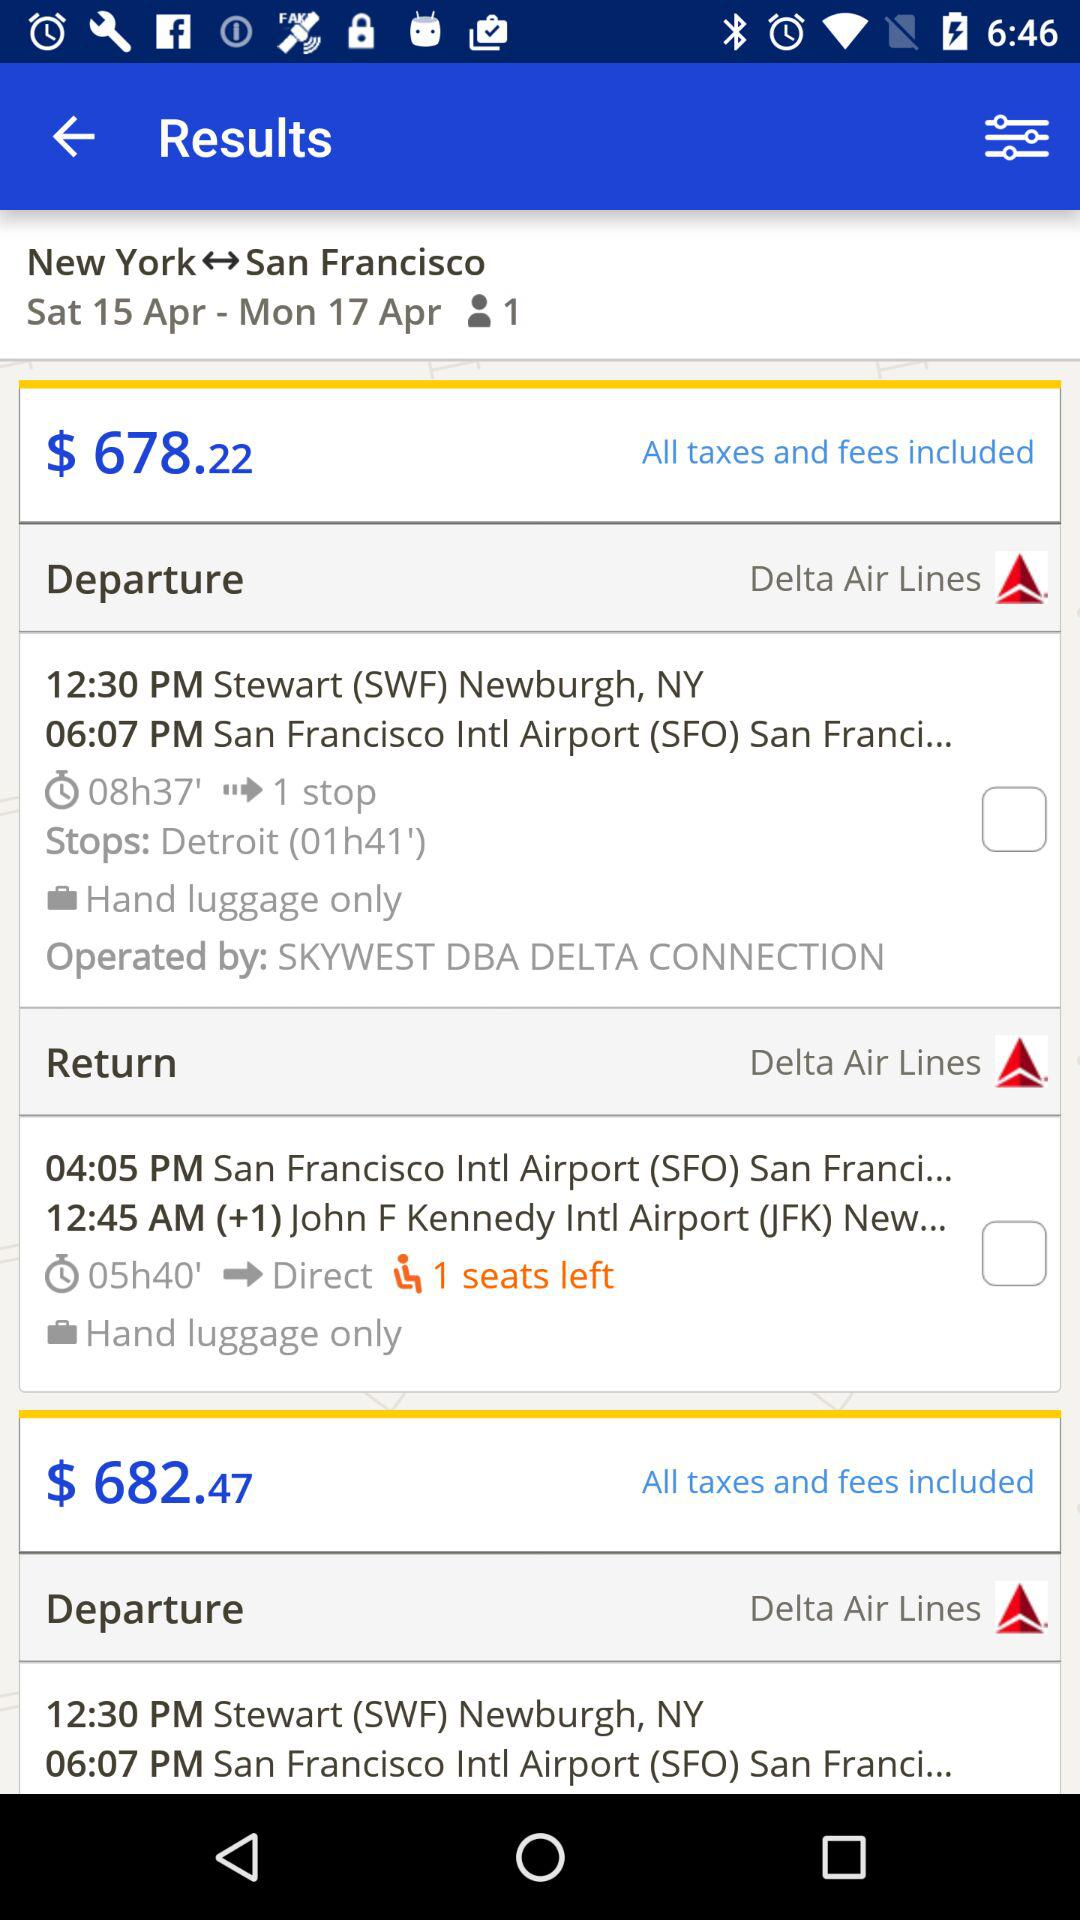How many stops are there in the first flight?
Answer the question using a single word or phrase. 1 